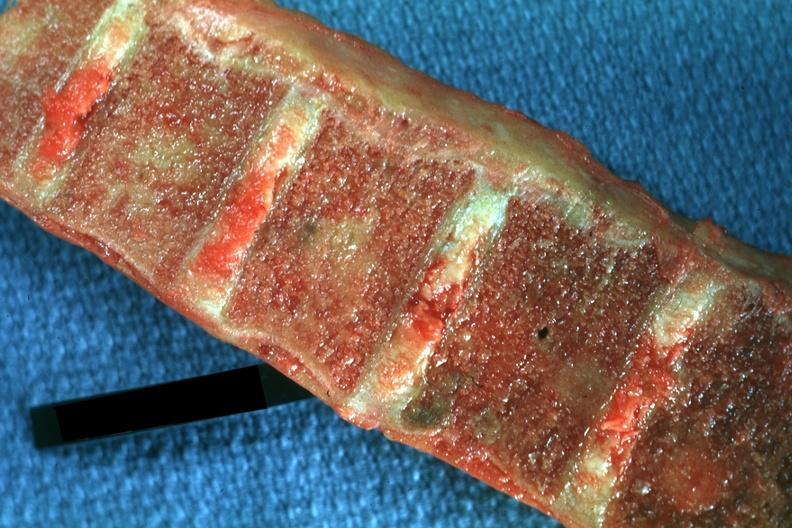s joints present?
Answer the question using a single word or phrase. Yes 